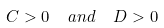Convert formula to latex. <formula><loc_0><loc_0><loc_500><loc_500>C > 0 \ \ a n d \ \ D > 0</formula> 